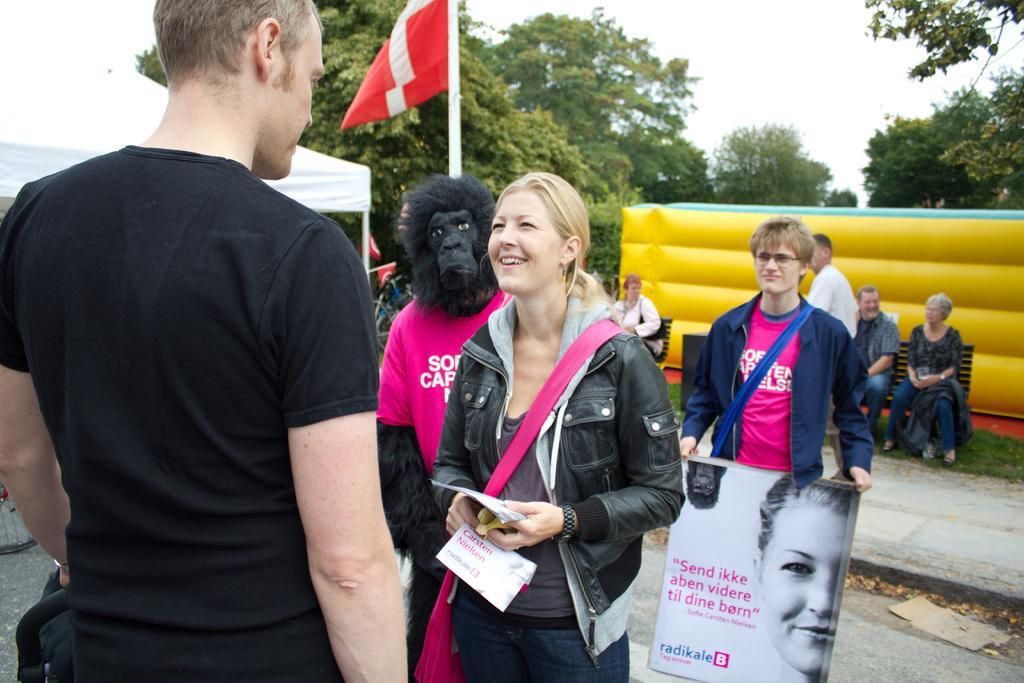In one or two sentences, can you explain what this image depicts? There is a man holding something on the left side. In front of him there is a lady wearing a bag and holding some papers in the hand. Behind her another person wearing a mask of a gorilla and standing. Also another person is holding a banner. In the background there are benches, yellow color thing, trees and sky. On the bench some people are sitting. On the left side there is a tent. 